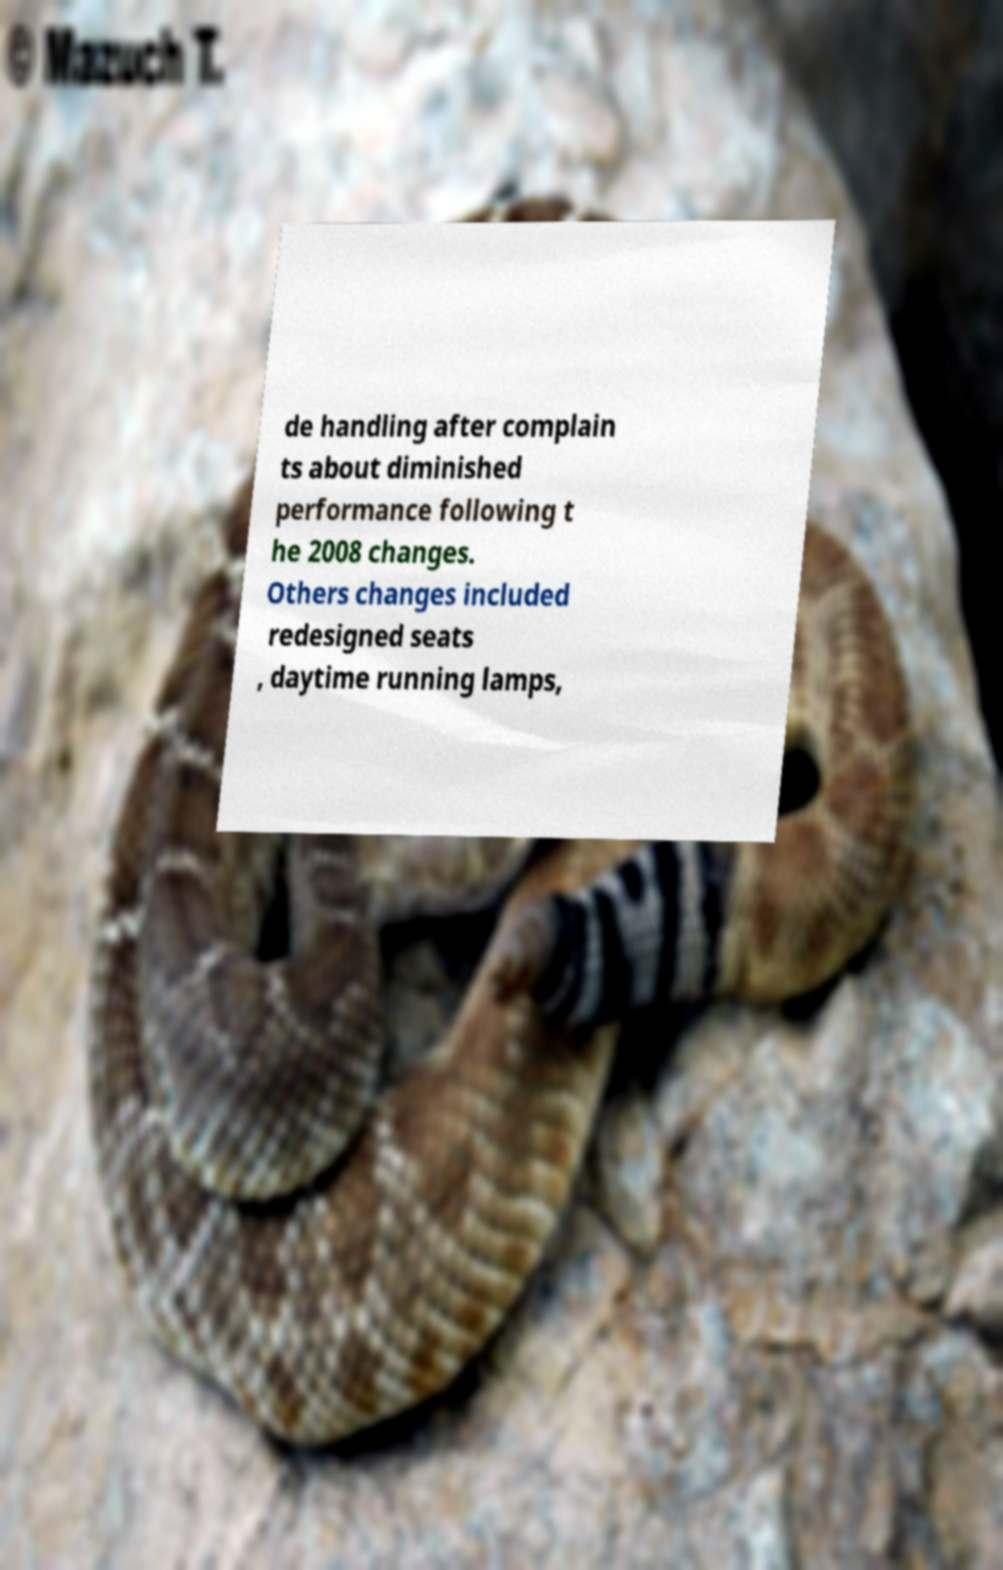What messages or text are displayed in this image? I need them in a readable, typed format. de handling after complain ts about diminished performance following t he 2008 changes. Others changes included redesigned seats , daytime running lamps, 